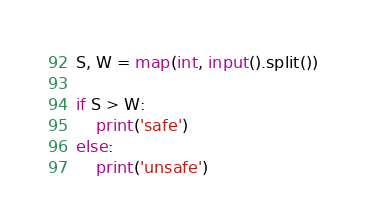Convert code to text. <code><loc_0><loc_0><loc_500><loc_500><_Python_>S, W = map(int, input().split())

if S > W:
    print('safe')
else:
    print('unsafe')
</code> 